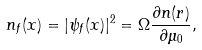<formula> <loc_0><loc_0><loc_500><loc_500>n _ { f } ( x ) = | \psi _ { f } ( x ) | ^ { 2 } = \Omega \frac { \partial n ( r ) } { \partial \mu _ { 0 } } ,</formula> 